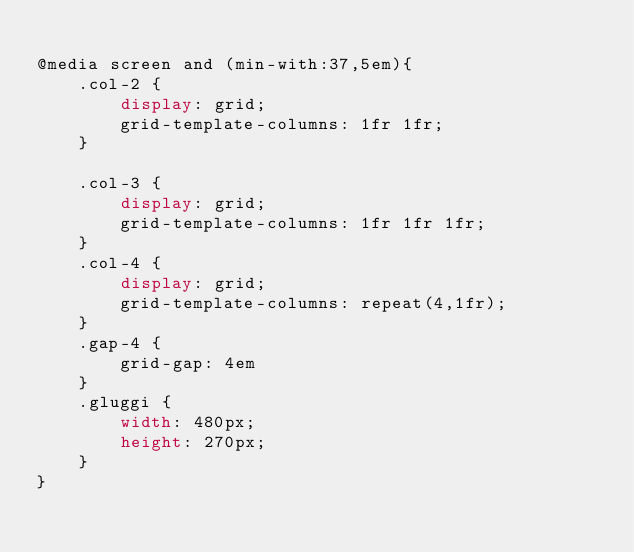Convert code to text. <code><loc_0><loc_0><loc_500><loc_500><_CSS_>
@media screen and (min-with:37,5em){
    .col-2 {
        display: grid;
        grid-template-columns: 1fr 1fr;
    }
    
    .col-3 {
        display: grid;
        grid-template-columns: 1fr 1fr 1fr;
    }
    .col-4 {
        display: grid;
        grid-template-columns: repeat(4,1fr);
    }
    .gap-4 {
        grid-gap: 4em
    }
    .gluggi {
        width: 480px;
        height: 270px;
    }
}</code> 